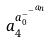Convert formula to latex. <formula><loc_0><loc_0><loc_500><loc_500>a _ { 4 } ^ { a _ { 0 } ^ { - ^ { - ^ { a _ { n } } } } }</formula> 